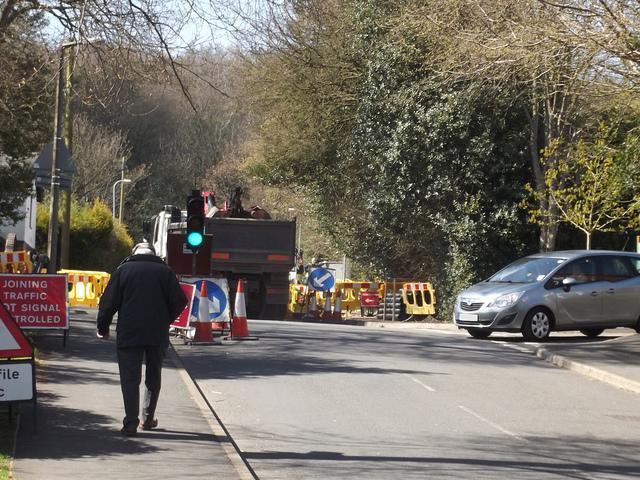What is the possible danger that will occur in the scene?
Indicate the correct response by choosing from the four available options to answer the question.
Options: Tree falling, construction collapsed, wrong signal, pedestrian hit. Wrong signal. 